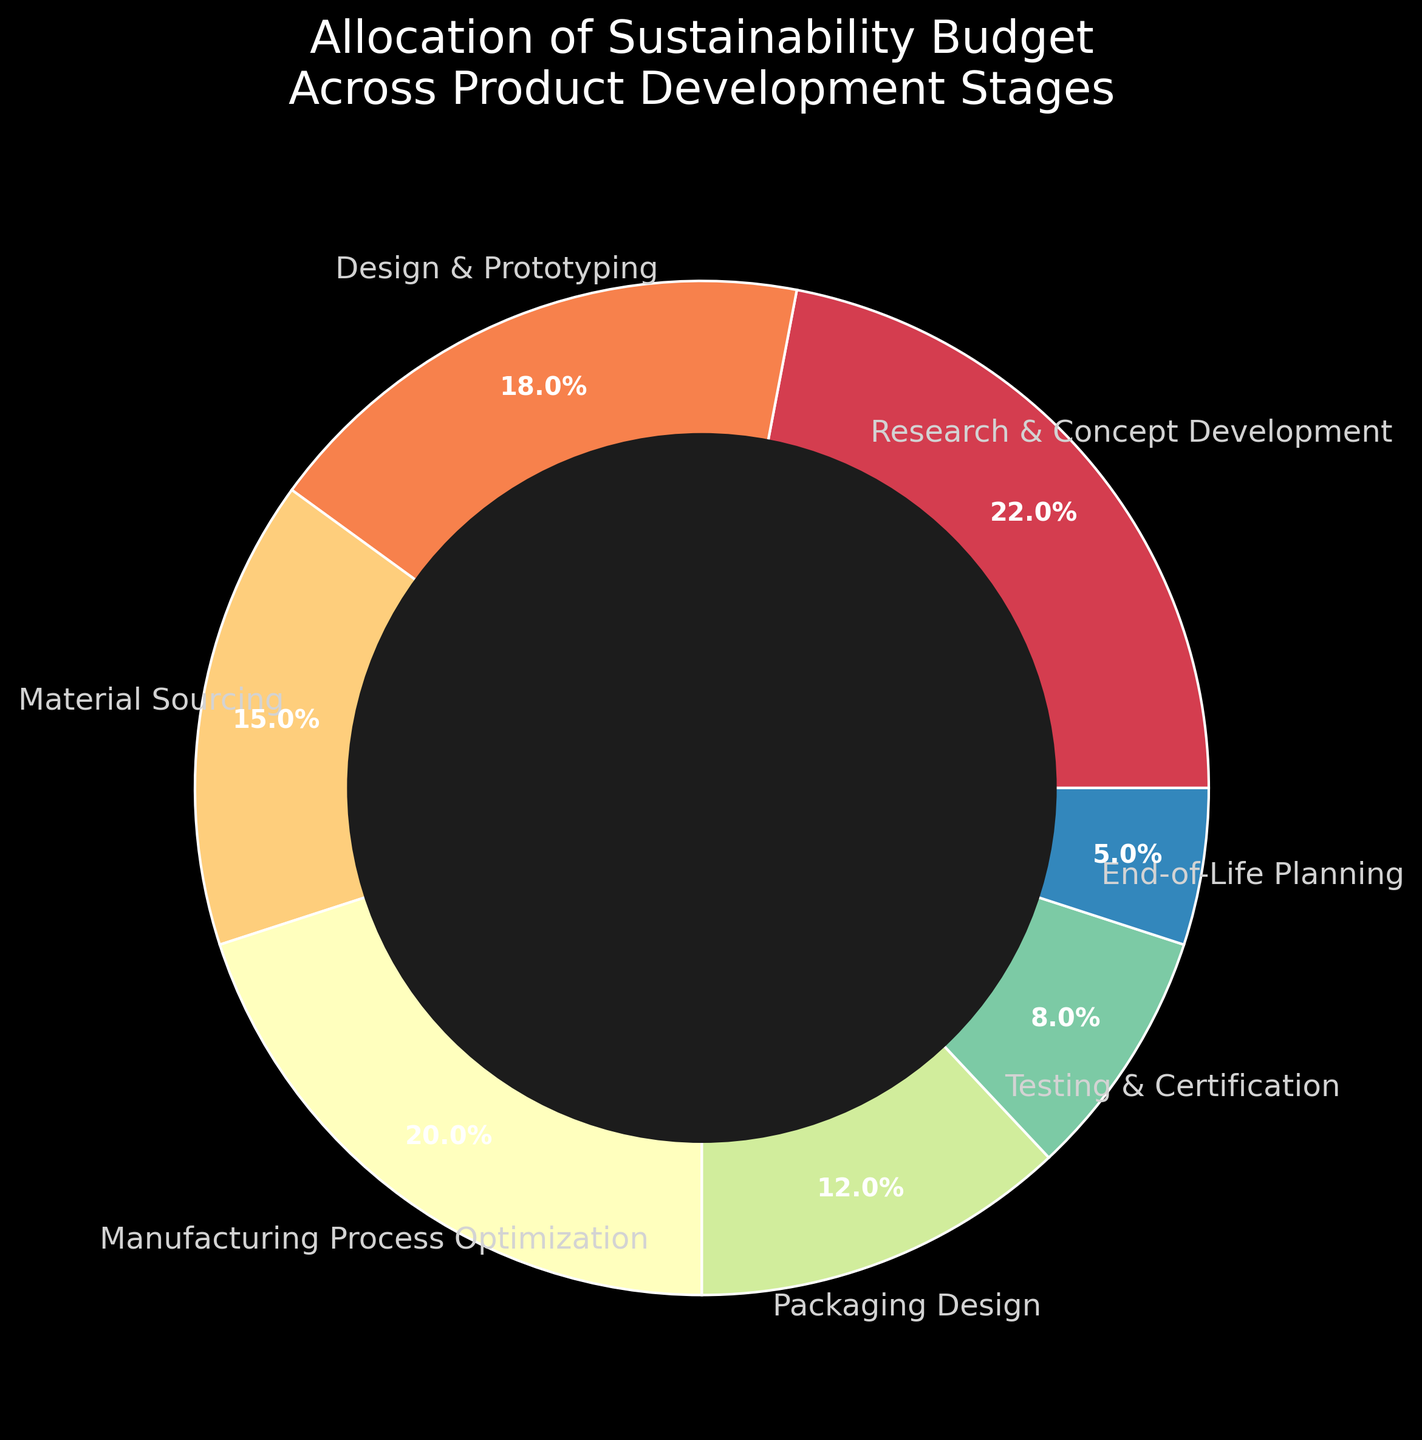What stage has the highest allocation percentage? By looking at the pie chart, the segment with the largest area represents the highest allocation. "Research & Concept Development" has the highest percentage at 22%.
Answer: Research & Concept Development Which stages receive a combined budget allocation of more than 50%? Adding up the percentages for "Research & Concept Development" (22%), "Design & Prototyping" (18%), and "Manufacturing Process Optimization" (20%) gives a total of 60%, which is more than 50%.
Answer: Research & Concept Development, Design & Prototyping, Manufacturing Process Optimization Is the budget for "Packaging Design" greater than the budget for "End-of-Life Planning"? Comparing the percentages for "Packaging Design" (12%) and "End-of-Life Planning" (5%), it is clear that 12% is greater than 5%.
Answer: Yes What is the difference in percentage allocation between "Material Sourcing" and "Testing & Certification"? Subtracting the percentage for "Testing & Certification" (8%) from "Material Sourcing" (15%) gives a difference: 15% - 8% = 7%.
Answer: 7% If the budget allocations for "Research & Concept Development" and "Manufacturing Process Optimization" were combined, what would be the total percentage? Adding the percentages for "Research & Concept Development" (22%) and "Manufacturing Process Optimization" (20%) gives a combined total: 22% + 20% = 42%.
Answer: 42% Which stage has the smallest budget allocation? The segment with the smallest area visually represents the smallest allocation, which is "End-of-Life Planning" at 5%.
Answer: End-of-Life Planning How do the budget allocations for "Design & Prototyping" and "Manufacturing Process Optimization" compare? The pie chart shows "Design & Prototyping" at 18% and "Manufacturing Process Optimization" at 20%. Comparing these, 20% is greater than 18%.
Answer: Manufacturing Process Optimization has a higher allocation What is the total percentage allocated to "Testing & Certification" and "End-of-Life Planning"? Adding the percentages for "Testing & Certification" (8%) and "End-of-Life Planning" (5%) gives a combined total: 8% + 5% = 13%.
Answer: 13% How much less is the budget for "Packaging Design" compared to "Research & Concept Development"? Subtracting the percentage for "Packaging Design" (12%) from "Research & Concept Development" (22%) gives the difference: 22% - 12% = 10%.
Answer: 10% Which stage has almost double the budget allocation of "End-of-Life Planning"? "End-of-Life Planning" has 5%, and almost double that would be 10%. "Packaging Design" with 12% is the closest figure.
Answer: Packaging Design 